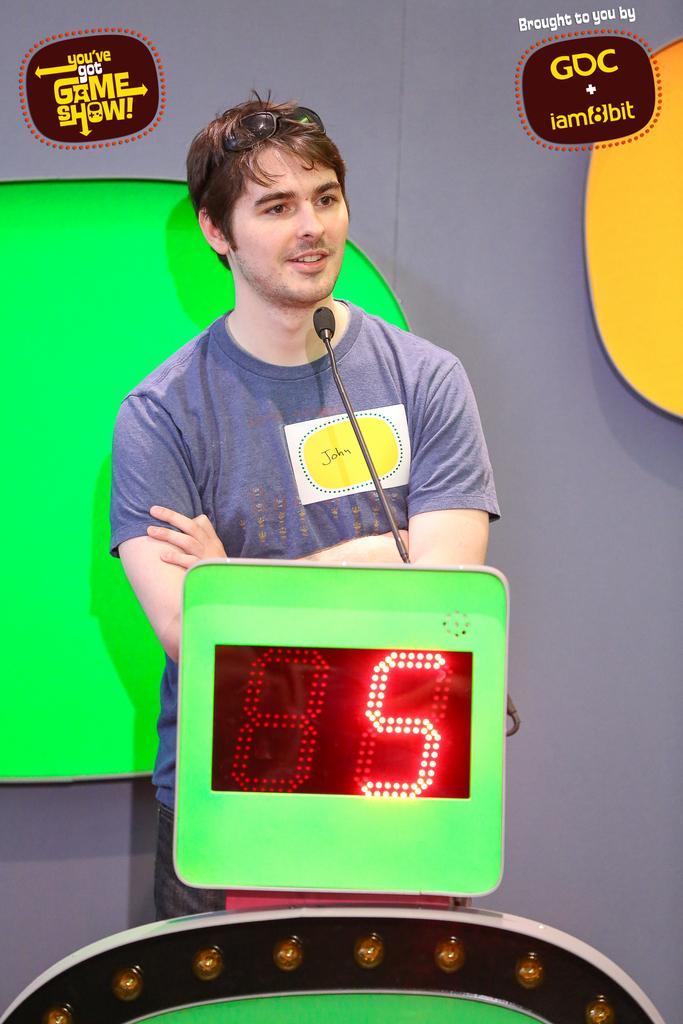How would you summarize this image in a sentence or two? In this picture we can see a man wearing a T-shirt, standing and smiling. We can see a microphone, digital number board and few objects. We can see a gray background. We can see some information.  